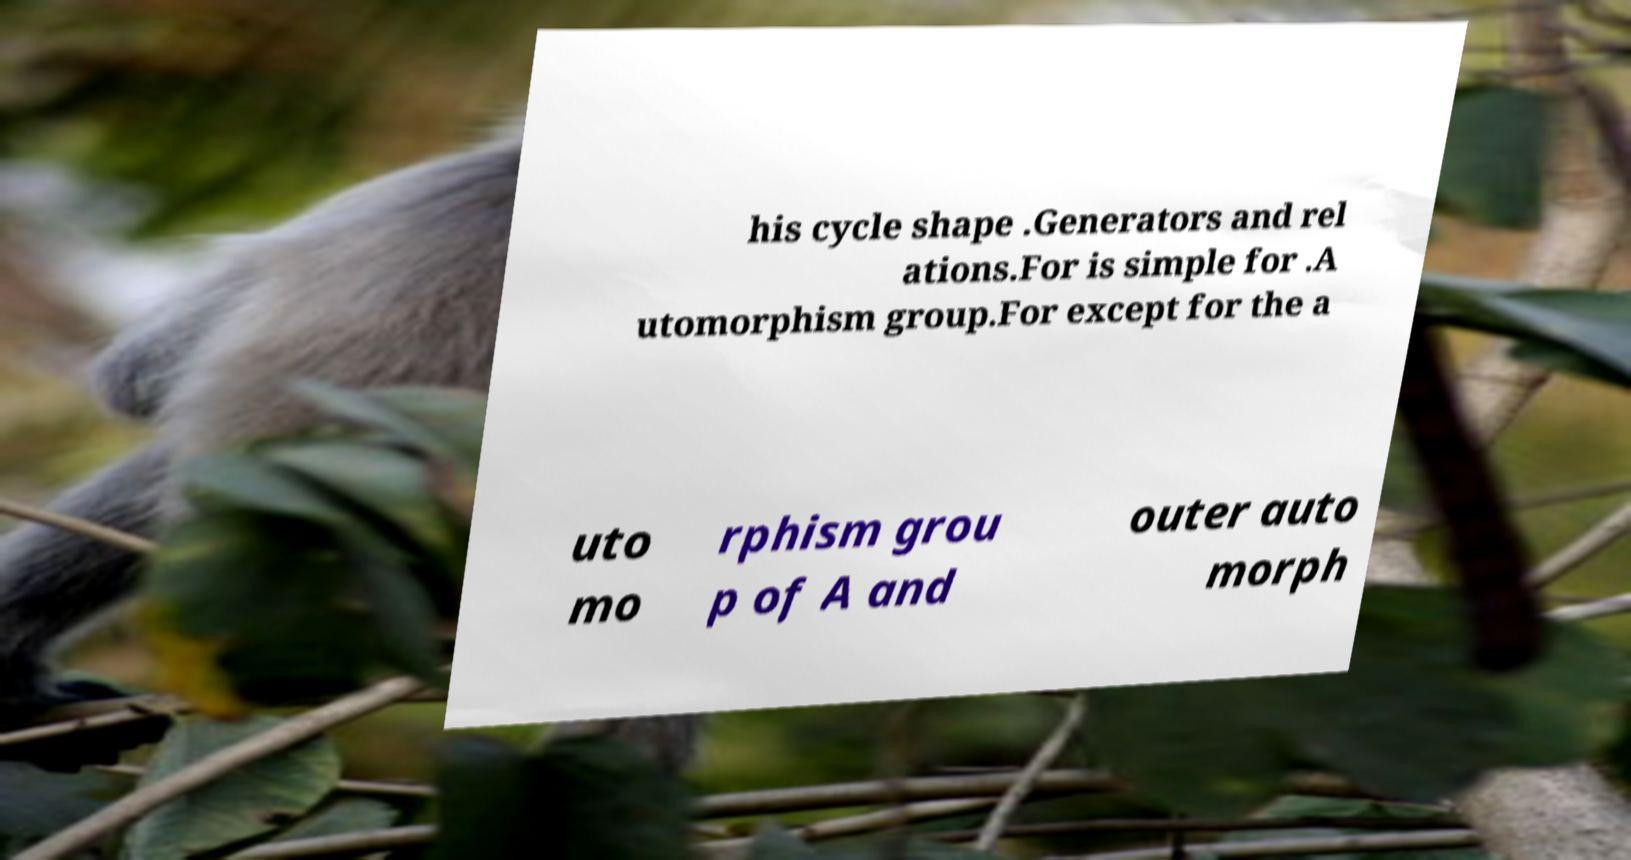There's text embedded in this image that I need extracted. Can you transcribe it verbatim? his cycle shape .Generators and rel ations.For is simple for .A utomorphism group.For except for the a uto mo rphism grou p of A and outer auto morph 